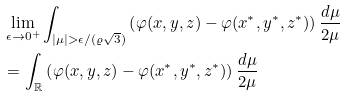Convert formula to latex. <formula><loc_0><loc_0><loc_500><loc_500>& \lim _ { \epsilon \to 0 ^ { + } } \int _ { | \mu | > \epsilon / ( \varrho \sqrt { 3 } ) } \left ( \varphi ( x , y , z ) - \varphi ( x ^ { \ast } , y ^ { \ast } , z ^ { \ast } ) \right ) \frac { d \mu } { 2 \mu } \\ & = \int _ { \mathbb { R } } \left ( \varphi ( x , y , z ) - \varphi ( x ^ { \ast } , y ^ { \ast } , z ^ { \ast } ) \right ) \frac { d \mu } { 2 \mu }</formula> 